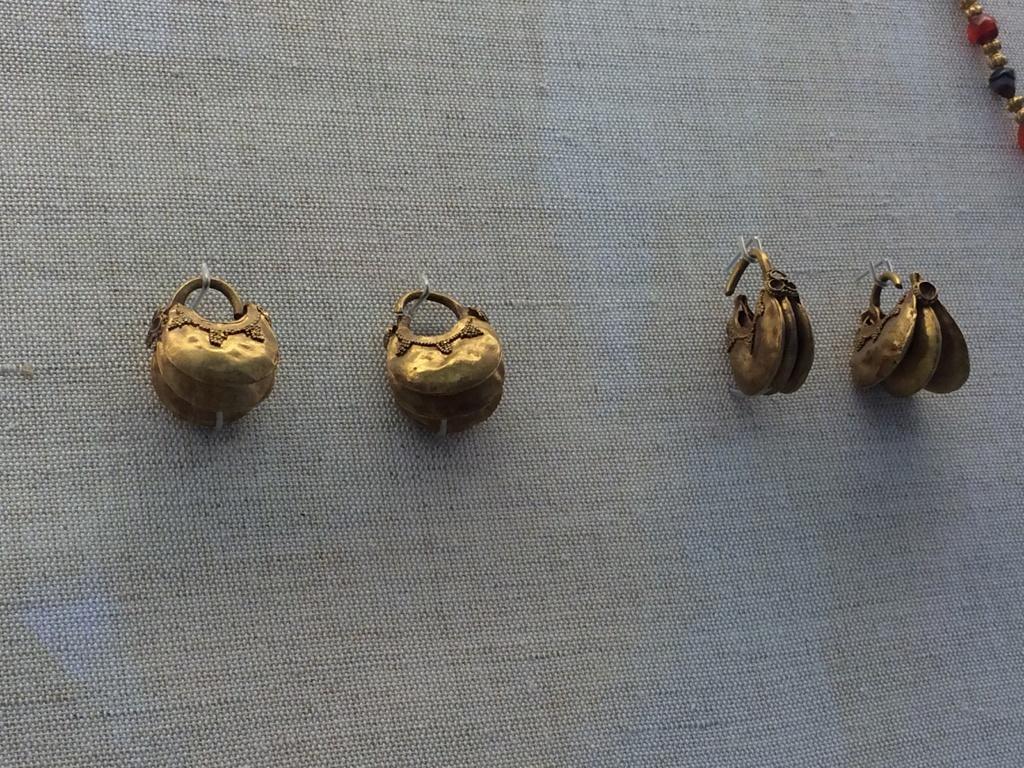Could you give a brief overview of what you see in this image? In this image there are few objects hanging on the wall. 